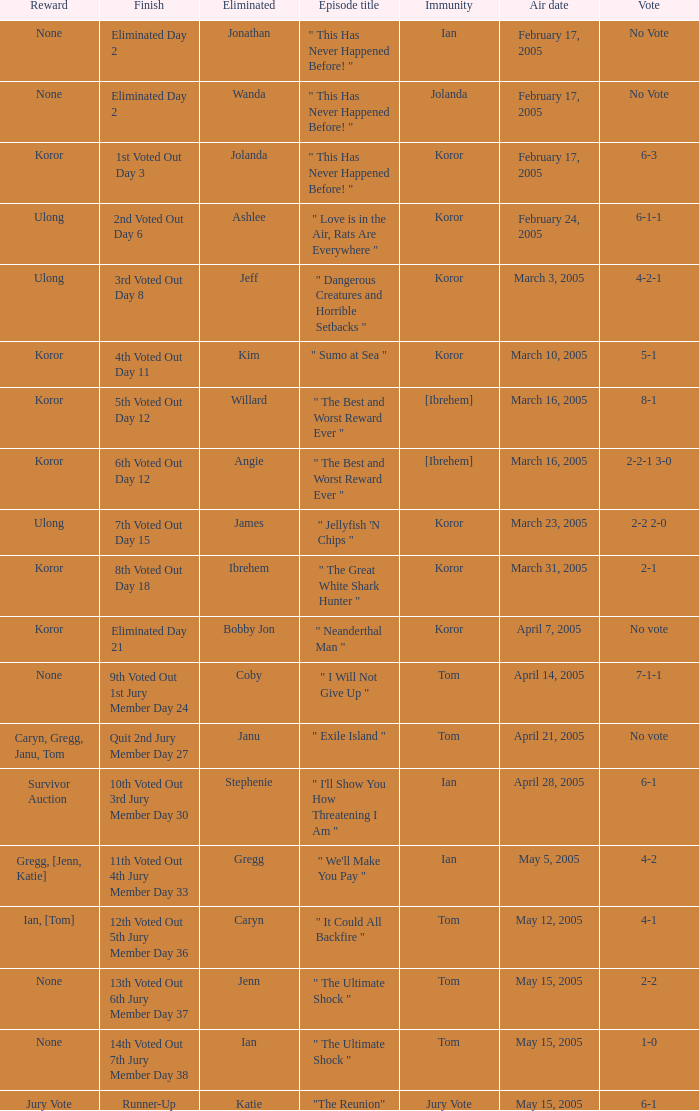How many persons had immunity in the episode when Wanda was eliminated? 1.0. 